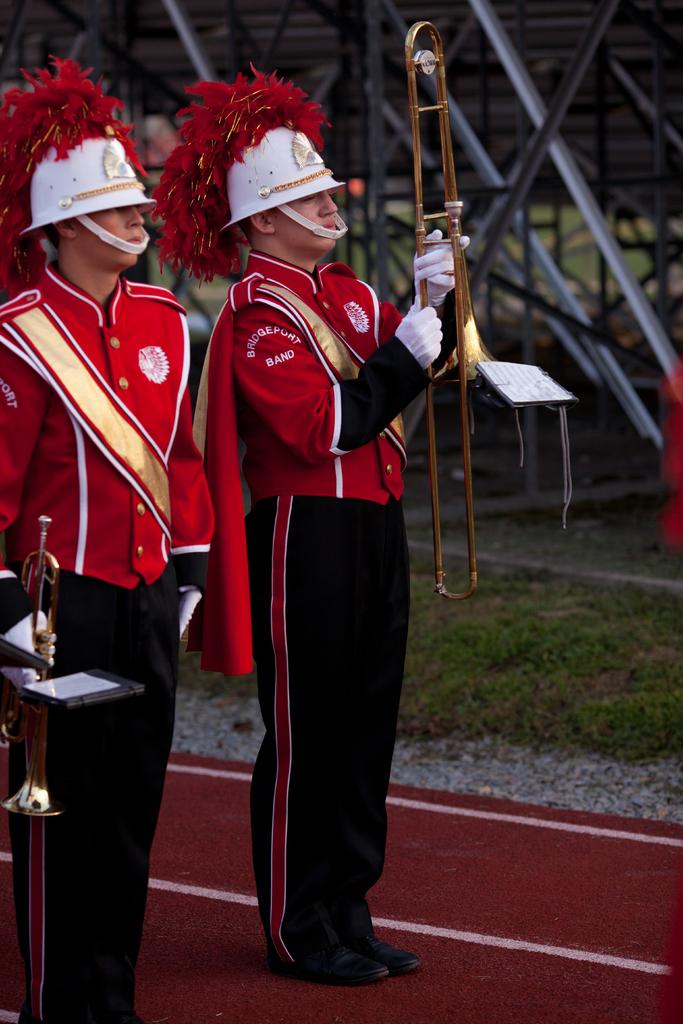What school is this marching band from?
Your answer should be very brief. Bridgeport. 